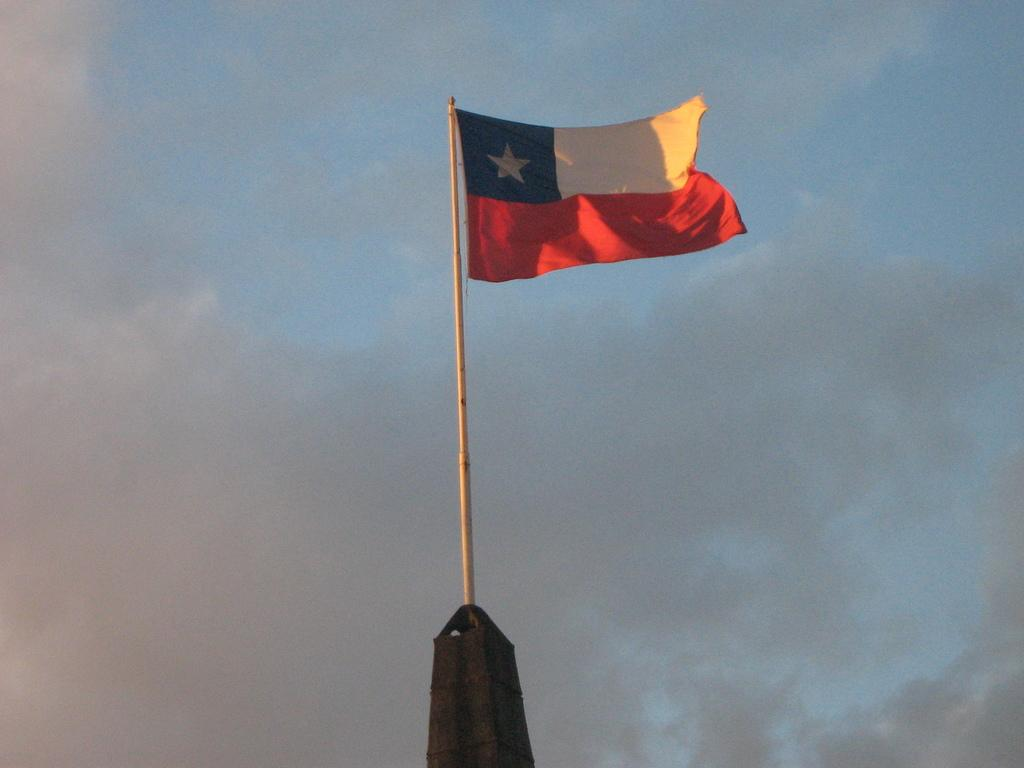What is the main object in the image? There is a flag in the image. How is the flag supported or held up? The flag is attached to a pole. Where is the flag located in relation to the image? The flag is at the top of the image. What can be seen in the background of the image? There are clouds in the background of the image. What color is the sky in the image? The sky is blue in the image. What type of leather is visible on the goose in the image? There is no goose or leather present in the image; it features a flag attached to a pole. 